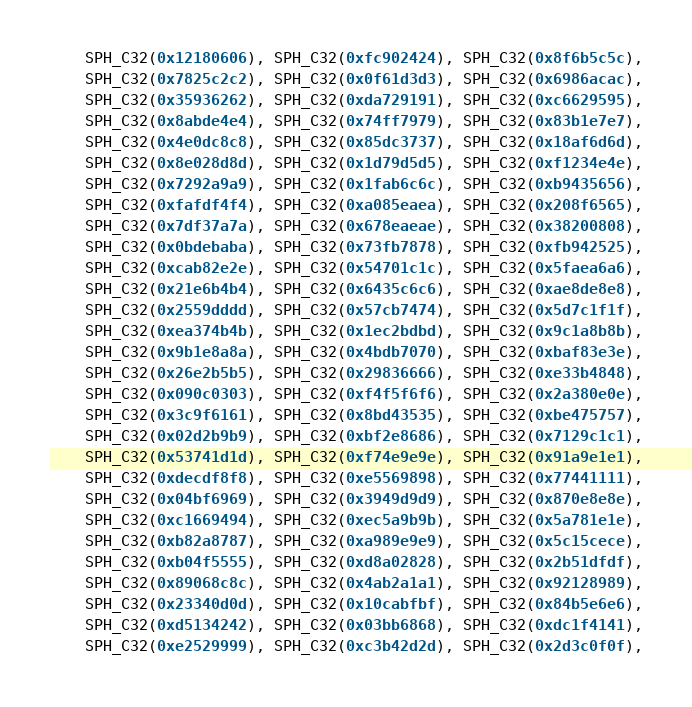<code> <loc_0><loc_0><loc_500><loc_500><_Cuda_>	SPH_C32(0x12180606), SPH_C32(0xfc902424), SPH_C32(0x8f6b5c5c),
	SPH_C32(0x7825c2c2), SPH_C32(0x0f61d3d3), SPH_C32(0x6986acac),
	SPH_C32(0x35936262), SPH_C32(0xda729191), SPH_C32(0xc6629595),
	SPH_C32(0x8abde4e4), SPH_C32(0x74ff7979), SPH_C32(0x83b1e7e7),
	SPH_C32(0x4e0dc8c8), SPH_C32(0x85dc3737), SPH_C32(0x18af6d6d),
	SPH_C32(0x8e028d8d), SPH_C32(0x1d79d5d5), SPH_C32(0xf1234e4e),
	SPH_C32(0x7292a9a9), SPH_C32(0x1fab6c6c), SPH_C32(0xb9435656),
	SPH_C32(0xfafdf4f4), SPH_C32(0xa085eaea), SPH_C32(0x208f6565),
	SPH_C32(0x7df37a7a), SPH_C32(0x678eaeae), SPH_C32(0x38200808),
	SPH_C32(0x0bdebaba), SPH_C32(0x73fb7878), SPH_C32(0xfb942525),
	SPH_C32(0xcab82e2e), SPH_C32(0x54701c1c), SPH_C32(0x5faea6a6),
	SPH_C32(0x21e6b4b4), SPH_C32(0x6435c6c6), SPH_C32(0xae8de8e8),
	SPH_C32(0x2559dddd), SPH_C32(0x57cb7474), SPH_C32(0x5d7c1f1f),
	SPH_C32(0xea374b4b), SPH_C32(0x1ec2bdbd), SPH_C32(0x9c1a8b8b),
	SPH_C32(0x9b1e8a8a), SPH_C32(0x4bdb7070), SPH_C32(0xbaf83e3e),
	SPH_C32(0x26e2b5b5), SPH_C32(0x29836666), SPH_C32(0xe33b4848),
	SPH_C32(0x090c0303), SPH_C32(0xf4f5f6f6), SPH_C32(0x2a380e0e),
	SPH_C32(0x3c9f6161), SPH_C32(0x8bd43535), SPH_C32(0xbe475757),
	SPH_C32(0x02d2b9b9), SPH_C32(0xbf2e8686), SPH_C32(0x7129c1c1),
	SPH_C32(0x53741d1d), SPH_C32(0xf74e9e9e), SPH_C32(0x91a9e1e1),
	SPH_C32(0xdecdf8f8), SPH_C32(0xe5569898), SPH_C32(0x77441111),
	SPH_C32(0x04bf6969), SPH_C32(0x3949d9d9), SPH_C32(0x870e8e8e),
	SPH_C32(0xc1669494), SPH_C32(0xec5a9b9b), SPH_C32(0x5a781e1e),
	SPH_C32(0xb82a8787), SPH_C32(0xa989e9e9), SPH_C32(0x5c15cece),
	SPH_C32(0xb04f5555), SPH_C32(0xd8a02828), SPH_C32(0x2b51dfdf),
	SPH_C32(0x89068c8c), SPH_C32(0x4ab2a1a1), SPH_C32(0x92128989),
	SPH_C32(0x23340d0d), SPH_C32(0x10cabfbf), SPH_C32(0x84b5e6e6),
	SPH_C32(0xd5134242), SPH_C32(0x03bb6868), SPH_C32(0xdc1f4141),
	SPH_C32(0xe2529999), SPH_C32(0xc3b42d2d), SPH_C32(0x2d3c0f0f),</code> 